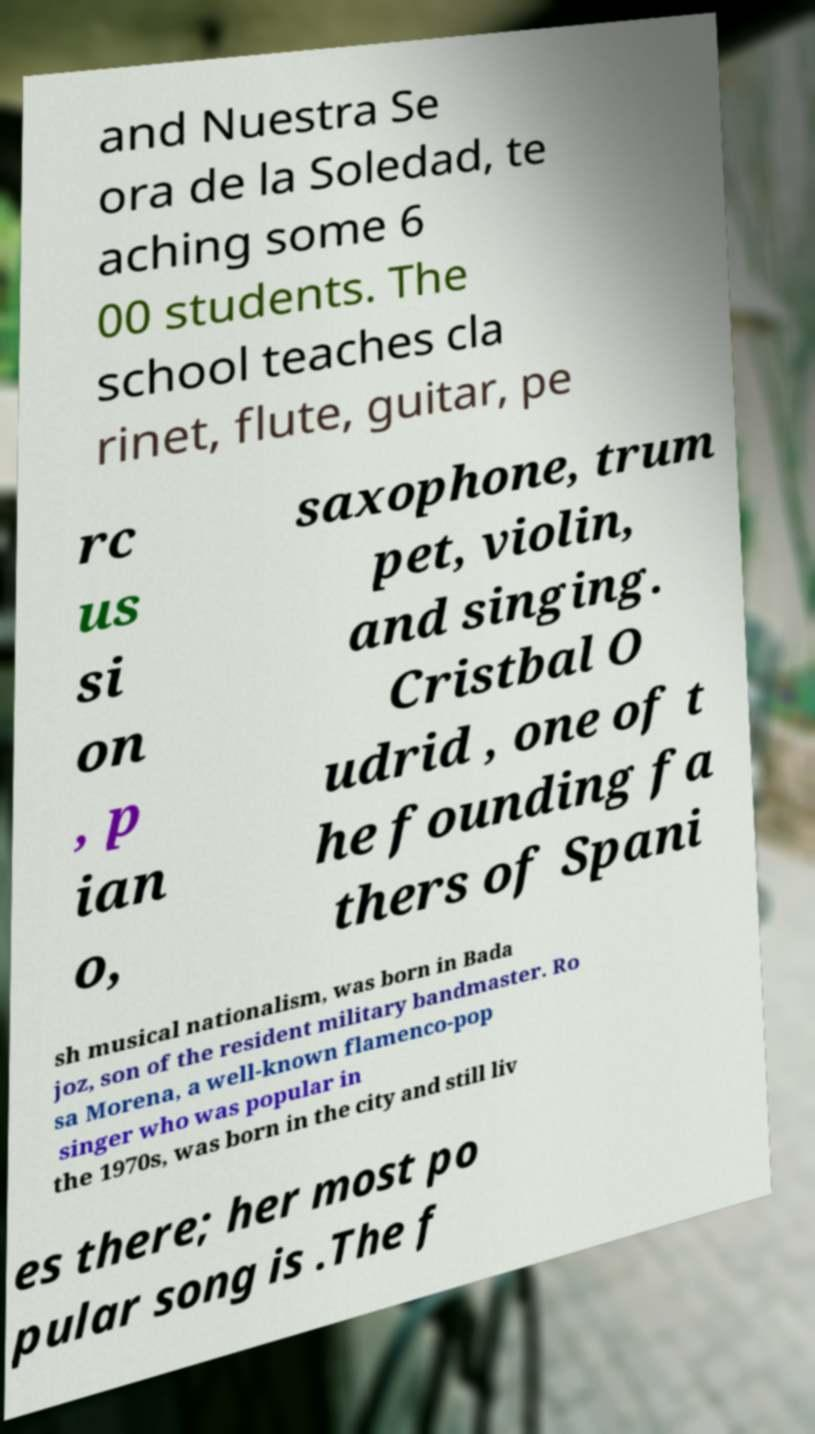What messages or text are displayed in this image? I need them in a readable, typed format. and Nuestra Se ora de la Soledad, te aching some 6 00 students. The school teaches cla rinet, flute, guitar, pe rc us si on , p ian o, saxophone, trum pet, violin, and singing. Cristbal O udrid , one of t he founding fa thers of Spani sh musical nationalism, was born in Bada joz, son of the resident military bandmaster. Ro sa Morena, a well-known flamenco-pop singer who was popular in the 1970s, was born in the city and still liv es there; her most po pular song is .The f 